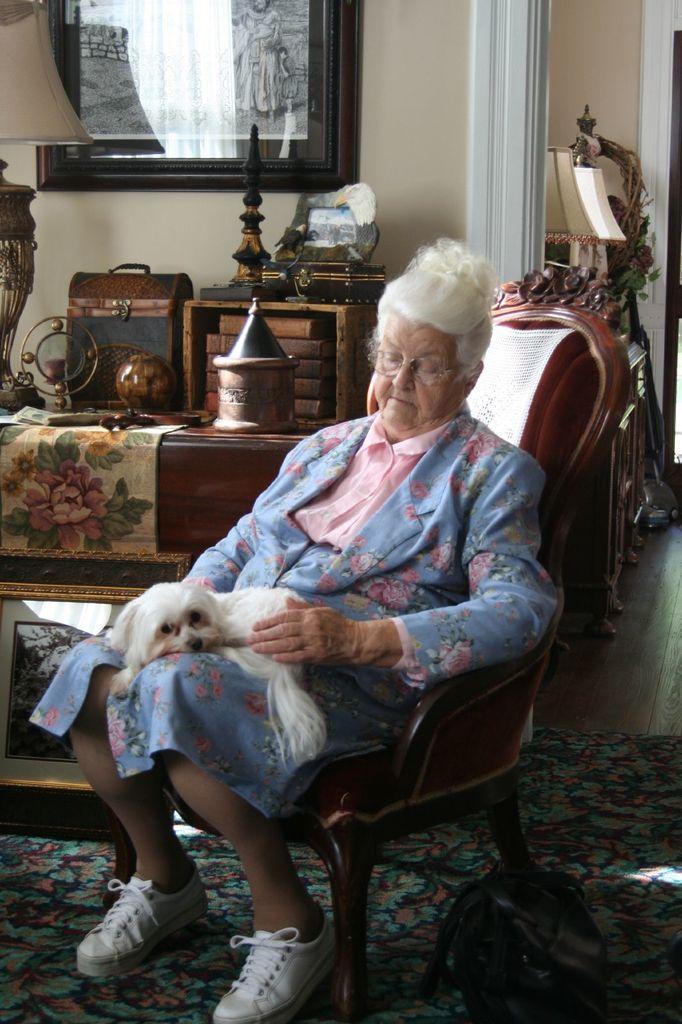Describe this image in one or two sentences. This is the picture of a lady in pink and blue dress sitting on the chair and a dog in her laps and behind there is a desk on which some things are placed. 